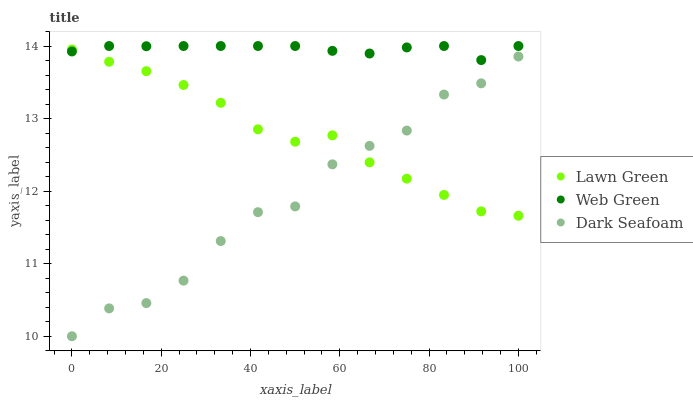Does Dark Seafoam have the minimum area under the curve?
Answer yes or no. Yes. Does Web Green have the maximum area under the curve?
Answer yes or no. Yes. Does Web Green have the minimum area under the curve?
Answer yes or no. No. Does Dark Seafoam have the maximum area under the curve?
Answer yes or no. No. Is Web Green the smoothest?
Answer yes or no. Yes. Is Dark Seafoam the roughest?
Answer yes or no. Yes. Is Dark Seafoam the smoothest?
Answer yes or no. No. Is Web Green the roughest?
Answer yes or no. No. Does Dark Seafoam have the lowest value?
Answer yes or no. Yes. Does Web Green have the lowest value?
Answer yes or no. No. Does Web Green have the highest value?
Answer yes or no. Yes. Does Dark Seafoam have the highest value?
Answer yes or no. No. Is Dark Seafoam less than Web Green?
Answer yes or no. Yes. Is Web Green greater than Dark Seafoam?
Answer yes or no. Yes. Does Dark Seafoam intersect Lawn Green?
Answer yes or no. Yes. Is Dark Seafoam less than Lawn Green?
Answer yes or no. No. Is Dark Seafoam greater than Lawn Green?
Answer yes or no. No. Does Dark Seafoam intersect Web Green?
Answer yes or no. No. 